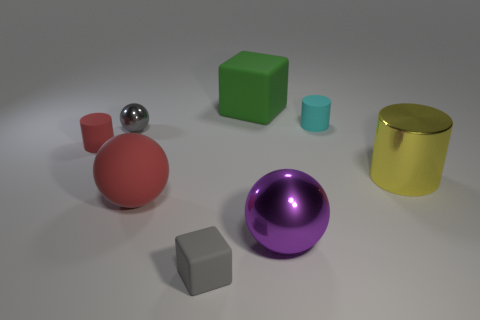Is there a tiny gray metal thing of the same shape as the green object? no 